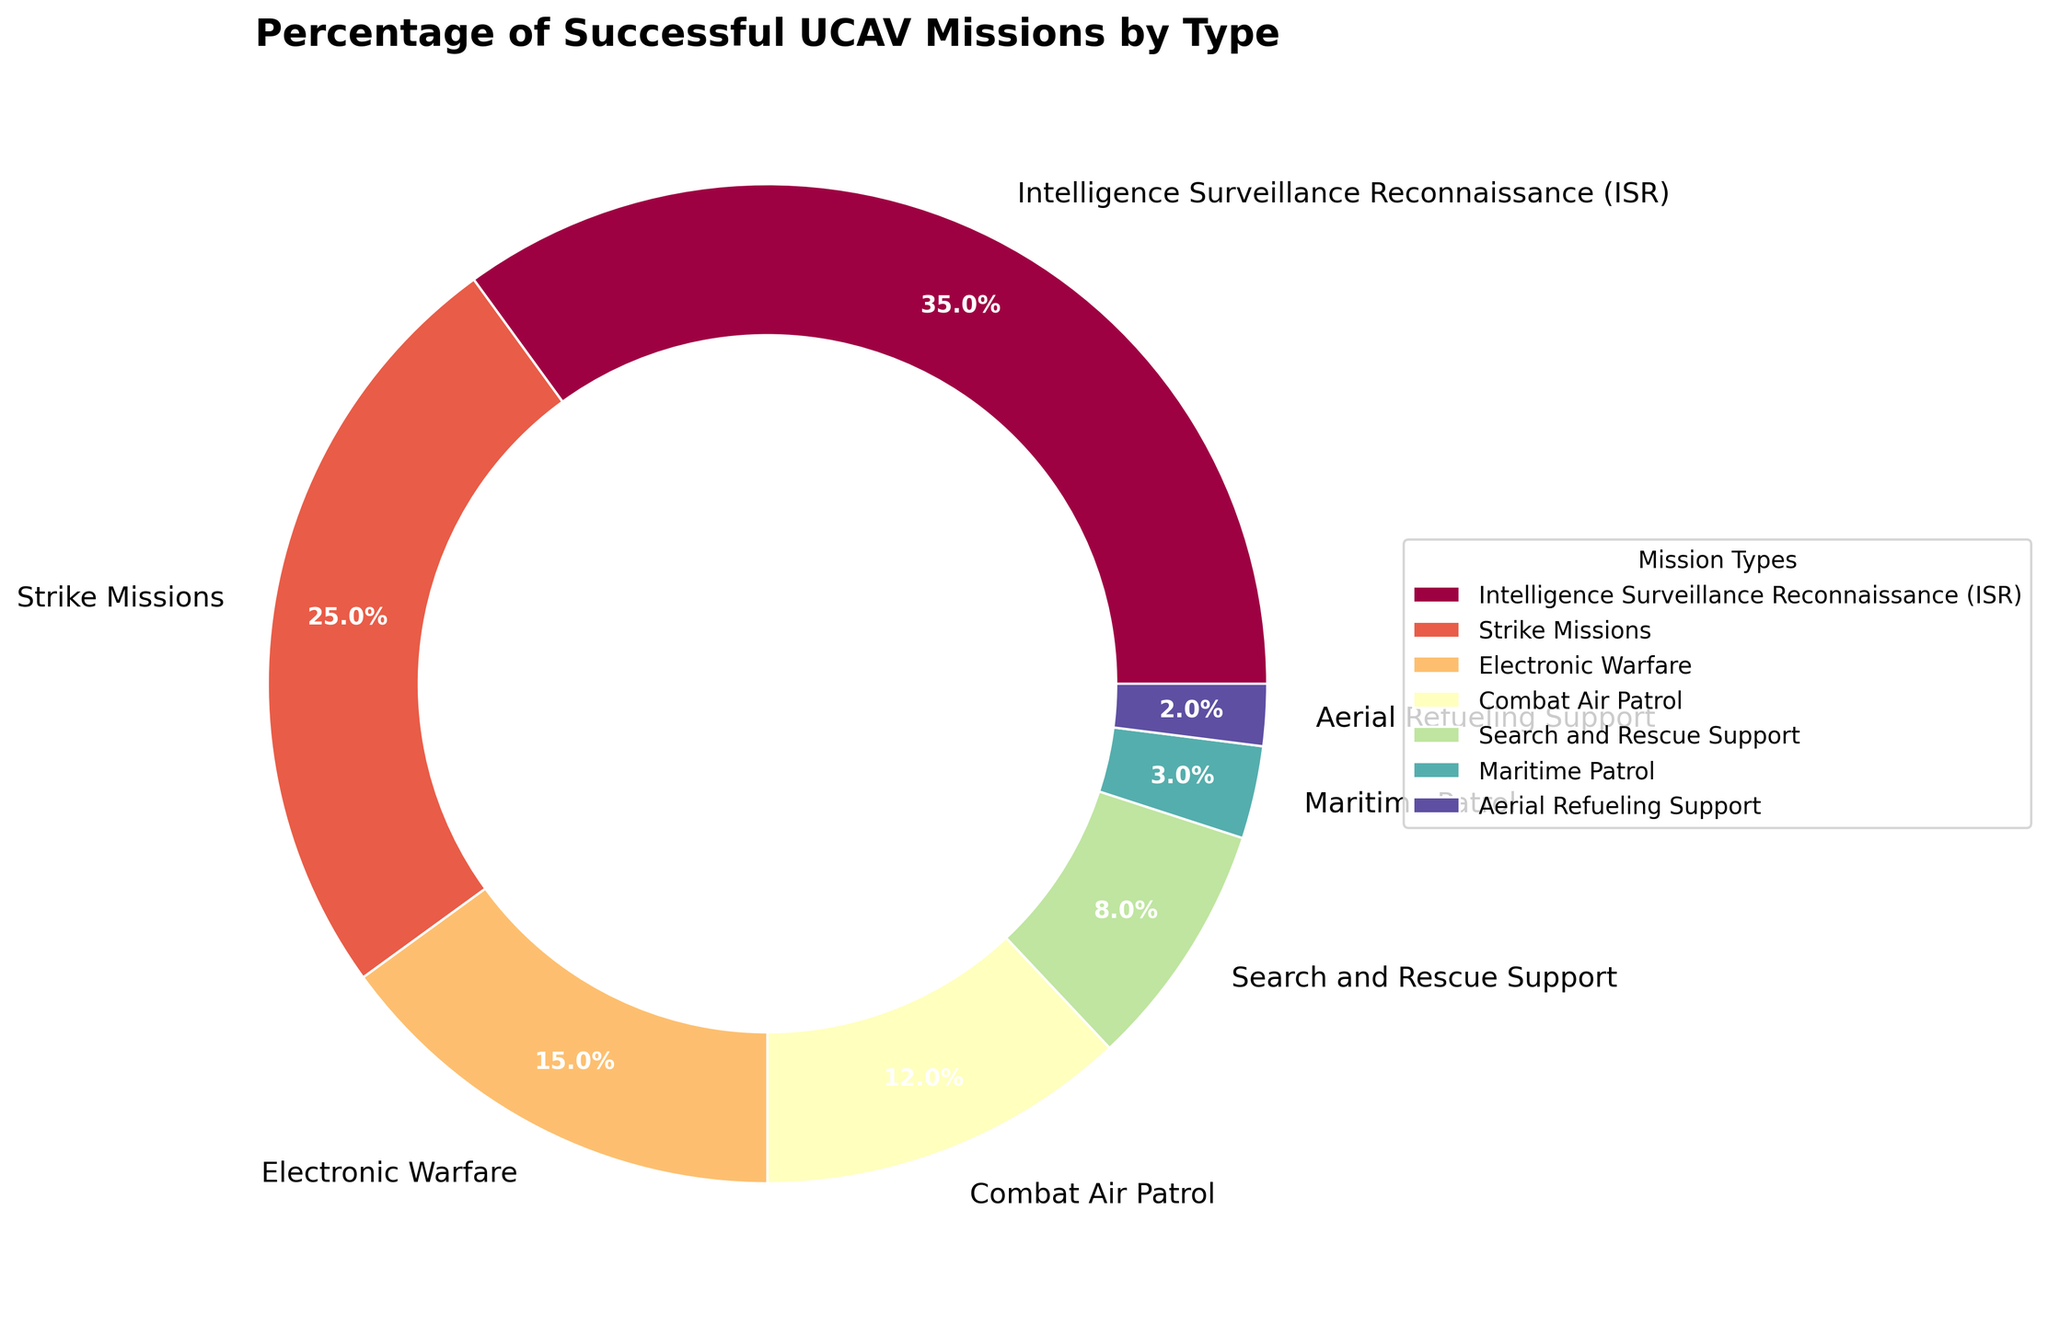What percentage of successful UCAV missions are Intelligence Surveillance Reconnaissance (ISR), Strike Missions, and Combat Air Patrol combined? To find the combined percentage, add the individual percentages of ISR, Strike Missions, and Combat Air Patrol. From the figure, ISR is 35%, Strike Missions are 25%, and Combat Air Patrol is 12%. Therefore, 35% + 25% + 12% = 72%.
Answer: 72% Which mission type has the smallest percentage of successful UCAV missions? The mission type with the smallest percentage will have the smallest wedge in the pie chart. From the figure, Aerial Refueling Support has the smallest percentage at 2%.
Answer: Aerial Refueling Support How much larger is the percentage of successful ISR missions compared to successful Search and Rescue Support missions? Find the difference between the percentage of ISR missions and Search and Rescue Support missions. ISR is 35% and Search and Rescue Support is 8%, so, 35% - 8% = 27%.
Answer: 27% Are there more successful Electronic Warfare missions or Search and Rescue Support missions, and by how much? Compare the percentages of Electronic Warfare missions and Search and Rescue Support missions. Electronic Warfare is 15% and Search and Rescue Support is 8%. The difference is 15% - 8% = 7%.
Answer: Electronic Warfare by 7% What is the combined percentage of successful missions involving Search and Rescue Support and Maritime Patrol? Add the individual percentages of Search and Rescue Support and Maritime Patrol missions. From the figure, Search and Rescue Support is 8% and Maritime Patrol is 3%. Therefore, 8% + 3% = 11%.
Answer: 11% Which mission type has the second highest percentage of successful UCAV missions? Determine the mission type with the second largest wedge in the pie chart. ISR has the highest at 35%. The next highest is Strike Missions at 25%.
Answer: Strike Missions Is the percentage of successful ISR missions greater than the sum of successful Maritime Patrol and Aerial Refueling Support missions? Compare the percentage of ISR missions and the combined percentages of Maritime Patrol and Aerial Refueling Support. ISR is 35%, while Maritime Patrol is 3% and Aerial Refueling Support is 2%. Combined, they are 3% + 2% = 5%. Hence, 35% is indeed greater than 5%.
Answer: Yes What is the overall percentage of successful missions that are either Strike Missions or Electronic Warfare? Add the percentages of Strike Missions and Electronic Warfare missions. From the figure, Strike Missions are 25% and Electronic Warfare is 15%. Therefore, 25% + 15% = 40%.
Answer: 40% How does the size (percentage) of Combat Air Patrol missions compare to ISR missions? Compare the percentage values of Combat Air Patrol and ISR missions. ISR is 35% and Combat Air Patrol is 12%, so ISR is significantly larger at 35% compared to 12%.
Answer: ISR is larger What is the average percentage of successful missions for Strike Missions, Electronic Warfare, and Maritime Patrol? Calculate the average by summing the percentages of these three missions and then dividing by three. Strike Missions are 25%, Electronic Warfare is 15%, and Maritime Patrol is 3%. (25% + 15% + 3%) / 3 = 43% / 3 ≈ 14.33%.
Answer: 14.33% 